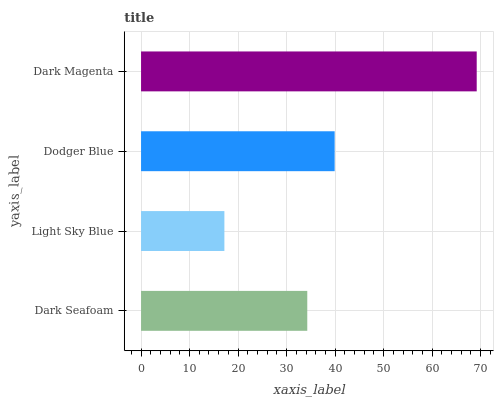Is Light Sky Blue the minimum?
Answer yes or no. Yes. Is Dark Magenta the maximum?
Answer yes or no. Yes. Is Dodger Blue the minimum?
Answer yes or no. No. Is Dodger Blue the maximum?
Answer yes or no. No. Is Dodger Blue greater than Light Sky Blue?
Answer yes or no. Yes. Is Light Sky Blue less than Dodger Blue?
Answer yes or no. Yes. Is Light Sky Blue greater than Dodger Blue?
Answer yes or no. No. Is Dodger Blue less than Light Sky Blue?
Answer yes or no. No. Is Dodger Blue the high median?
Answer yes or no. Yes. Is Dark Seafoam the low median?
Answer yes or no. Yes. Is Light Sky Blue the high median?
Answer yes or no. No. Is Dodger Blue the low median?
Answer yes or no. No. 